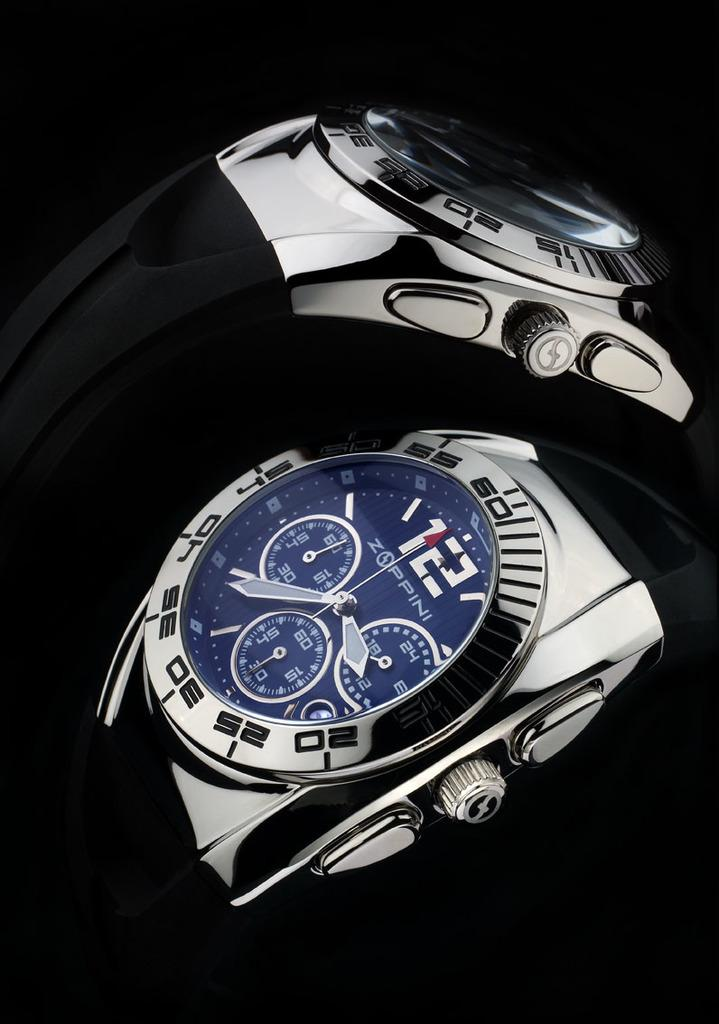Provide a one-sentence caption for the provided image. A couple of shiny watches by Zoppini look expensive. 